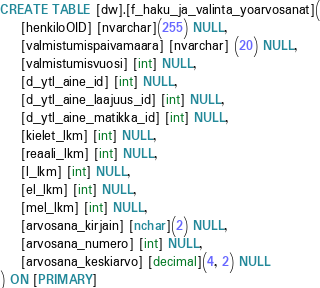<code> <loc_0><loc_0><loc_500><loc_500><_SQL_>
CREATE TABLE [dw].[f_haku_ja_valinta_yoarvosanat](
	[henkiloOID] [nvarchar](255) NULL,
	[valmistumispaivamaara] [nvarchar] (20) NULL,
	[valmistumisvuosi] [int] NULL,
	[d_ytl_aine_id] [int] NULL,
	[d_ytl_aine_laajuus_id] [int] NULL,
	[d_ytl_aine_matikka_id] [int] NULL,
	[kielet_lkm] [int] NULL,
	[reaali_lkm] [int] NULL,
	[l_lkm] [int] NULL,
	[el_lkm] [int] NULL,
	[mel_lkm] [int] NULL,
	[arvosana_kirjain] [nchar](2) NULL,
	[arvosana_numero] [int] NULL,
	[arvosana_keskiarvo] [decimal](4, 2) NULL
) ON [PRIMARY]




</code> 